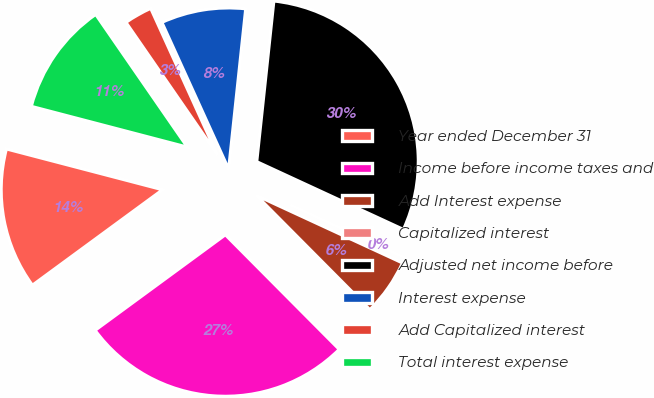Convert chart to OTSL. <chart><loc_0><loc_0><loc_500><loc_500><pie_chart><fcel>Year ended December 31<fcel>Income before income taxes and<fcel>Add Interest expense<fcel>Capitalized interest<fcel>Adjusted net income before<fcel>Interest expense<fcel>Add Capitalized interest<fcel>Total interest expense<nl><fcel>14.14%<fcel>27.38%<fcel>5.66%<fcel>0.0%<fcel>30.2%<fcel>8.48%<fcel>2.83%<fcel>11.31%<nl></chart> 